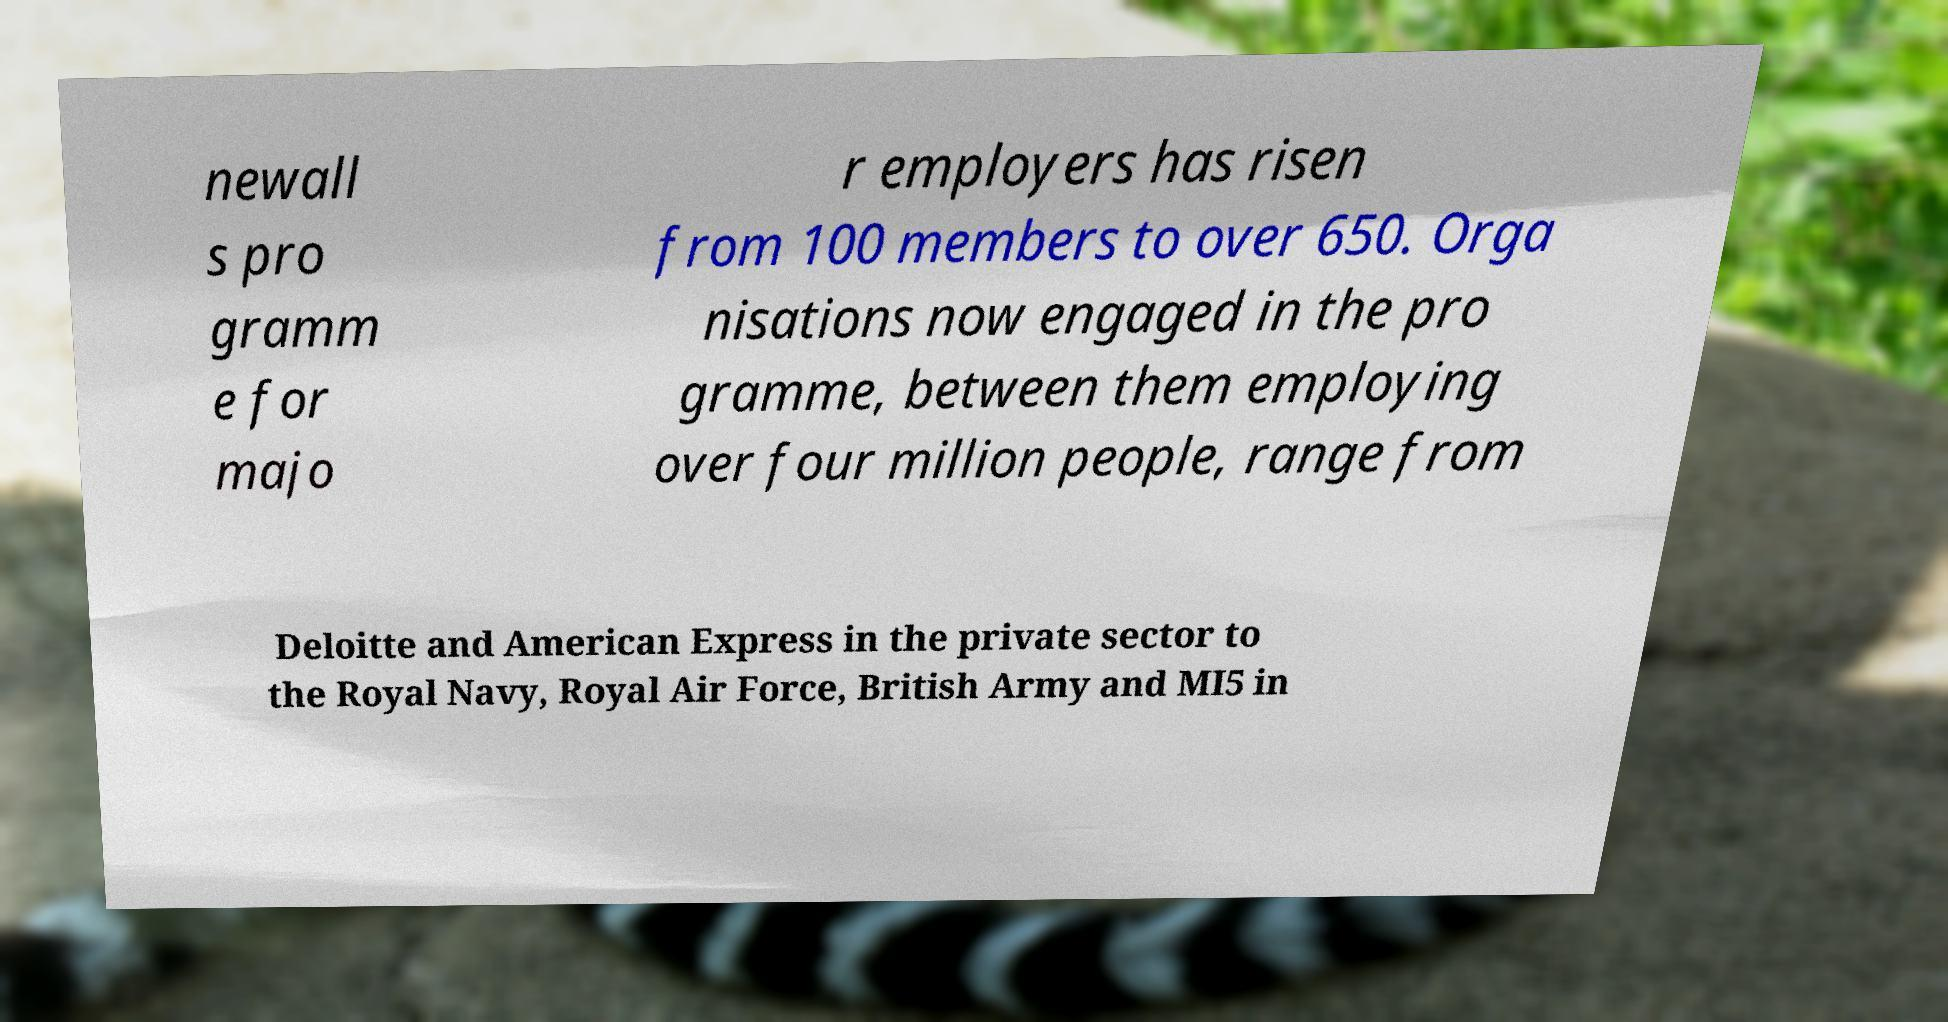For documentation purposes, I need the text within this image transcribed. Could you provide that? newall s pro gramm e for majo r employers has risen from 100 members to over 650. Orga nisations now engaged in the pro gramme, between them employing over four million people, range from Deloitte and American Express in the private sector to the Royal Navy, Royal Air Force, British Army and MI5 in 